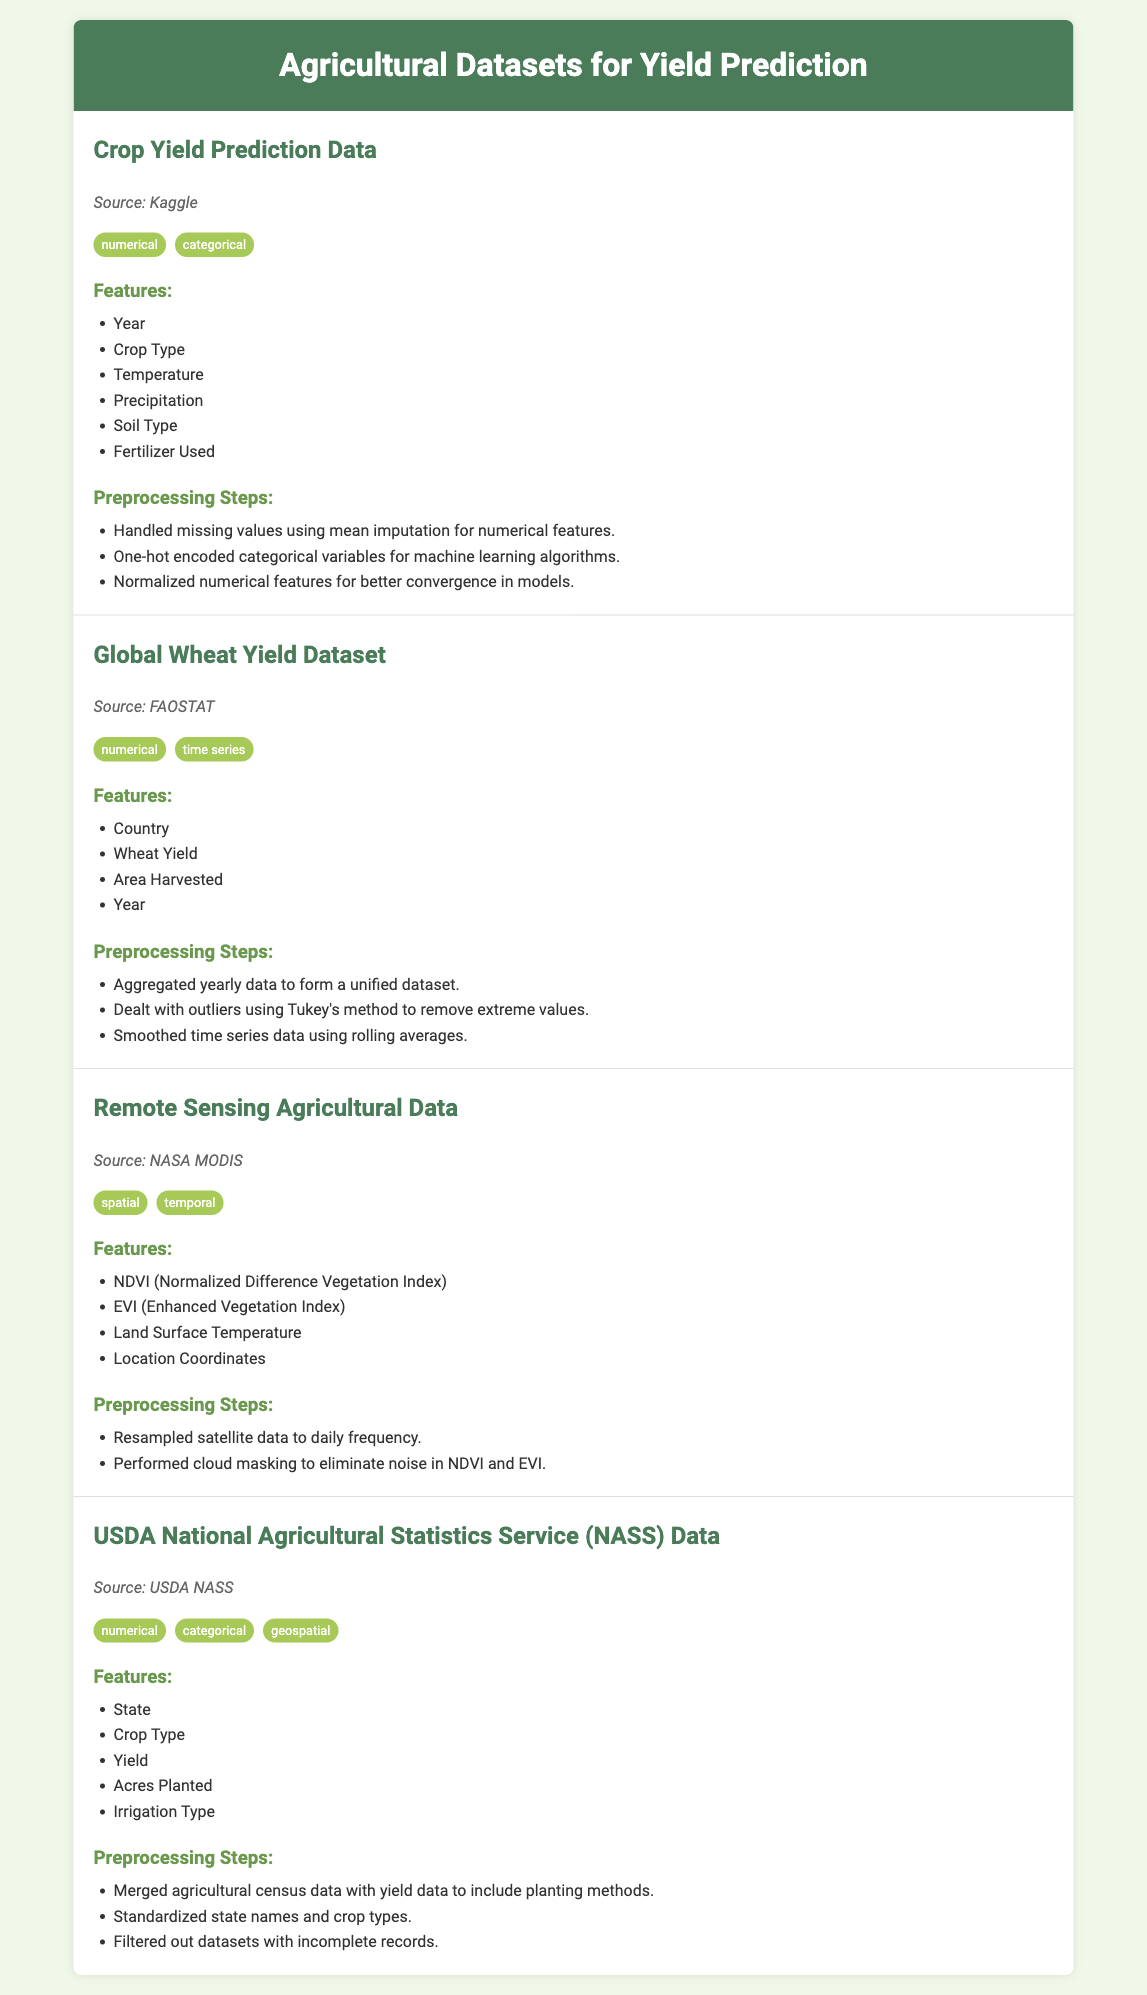What is the source of the Crop Yield Prediction Data? The source is explicitly mentioned in the document for each dataset, specifically stating that the Crop Yield Prediction Data comes from Kaggle.
Answer: Kaggle What features are included in the Global Wheat Yield Dataset? The features listed for the Global Wheat Yield Dataset include Country, Wheat Yield, Area Harvested, and Year.
Answer: Country, Wheat Yield, Area Harvested, Year Which dataset includes NDVI as a feature? The document details that the Remote Sensing Agricultural Data includes NDVI (Normalized Difference Vegetation Index) as one of its features.
Answer: Remote Sensing Agricultural Data What preprocessing step was done for cloud masking? It indicates the preprocessing steps taken for the Remote Sensing Agricultural Data, mentioning cloud masking to eliminate noise in NDVI and EVI.
Answer: Cloud masking How many features are listed for the USDA National Agricultural Statistics Service Data? The document lists five features for the USDA NASS Data: State, Crop Type, Yield, Acres Planted, and Irrigation Type, making it a total of five.
Answer: Five Which dataset addresses outliers using Tukey's method? The Global Wheat Yield Dataset uses Tukey's method to deal with outliers, as stated in the preprocessing steps associated with it.
Answer: Global Wheat Yield Dataset What type of data does the Remote Sensing Agricultural Data involve? The document classifies the Remote Sensing Agricultural Data as both spatial and temporal based on the tags provided.
Answer: Spatial, temporal What type of categorical preprocessing was performed on Crop Yield Prediction Data? The preprocessing steps for the Crop Yield Prediction Data included one-hot encoding categorical variables, specifically mentioned for machine learning algorithms.
Answer: One-hot encoding What is the source of the Remote Sensing Agricultural Data? The source for the Remote Sensing Agricultural Data is noted in the document as NASA MODIS.
Answer: NASA MODIS 